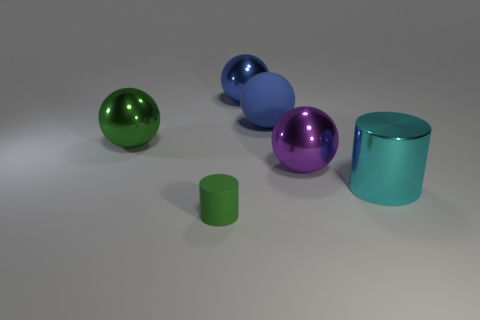What is the size of the cyan thing that is the same shape as the tiny green thing?
Provide a succinct answer. Large. There is a metal object that is to the right of the big shiny sphere that is on the right side of the large blue shiny thing; what shape is it?
Offer a very short reply. Cylinder. What number of gray things are either big metallic spheres or big cylinders?
Your response must be concise. 0. The big cylinder has what color?
Offer a very short reply. Cyan. Do the green matte cylinder and the cyan shiny cylinder have the same size?
Offer a very short reply. No. Is there any other thing that is the same shape as the tiny green object?
Ensure brevity in your answer.  Yes. Do the large green thing and the cylinder that is behind the tiny object have the same material?
Keep it short and to the point. Yes. There is a big metallic thing that is left of the tiny green object; does it have the same color as the big shiny cylinder?
Give a very brief answer. No. How many objects are in front of the purple thing and behind the large purple thing?
Provide a succinct answer. 0. How many other things are there of the same material as the green cylinder?
Your answer should be very brief. 1. 